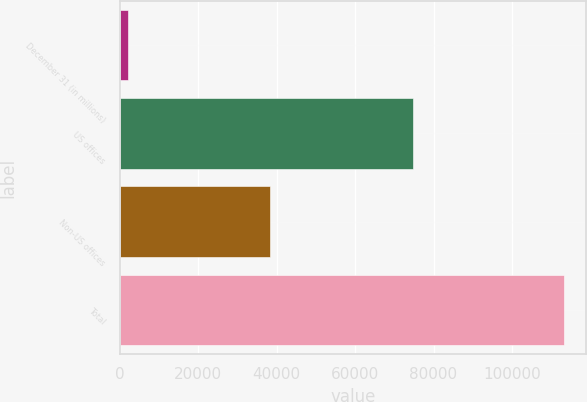Convert chart. <chart><loc_0><loc_0><loc_500><loc_500><bar_chart><fcel>December 31 (in millions)<fcel>US offices<fcel>Non-US offices<fcel>Total<nl><fcel>2013<fcel>74804<fcel>38412<fcel>113216<nl></chart> 